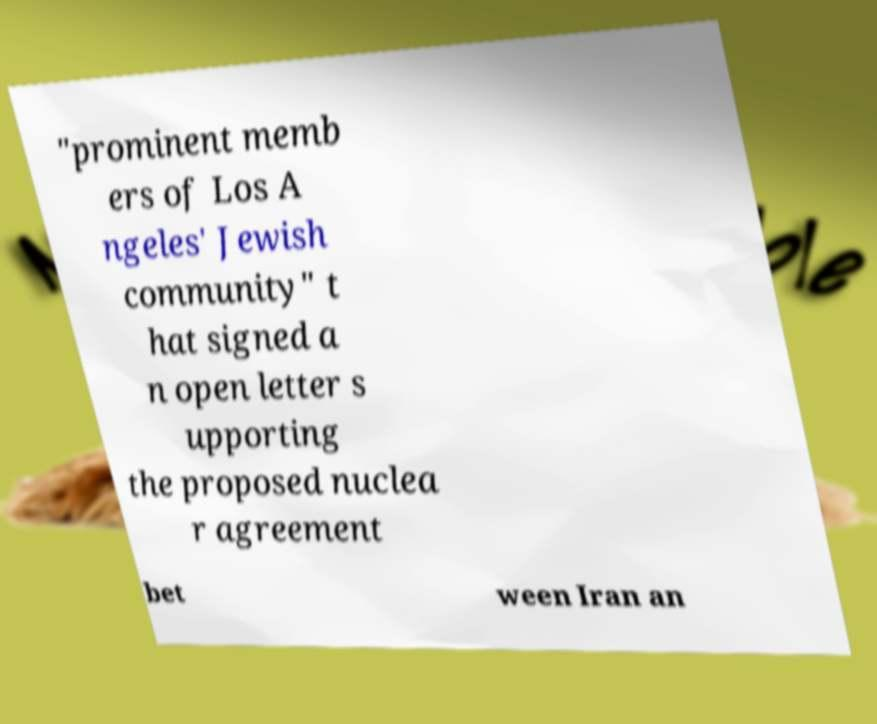There's text embedded in this image that I need extracted. Can you transcribe it verbatim? "prominent memb ers of Los A ngeles' Jewish community" t hat signed a n open letter s upporting the proposed nuclea r agreement bet ween Iran an 